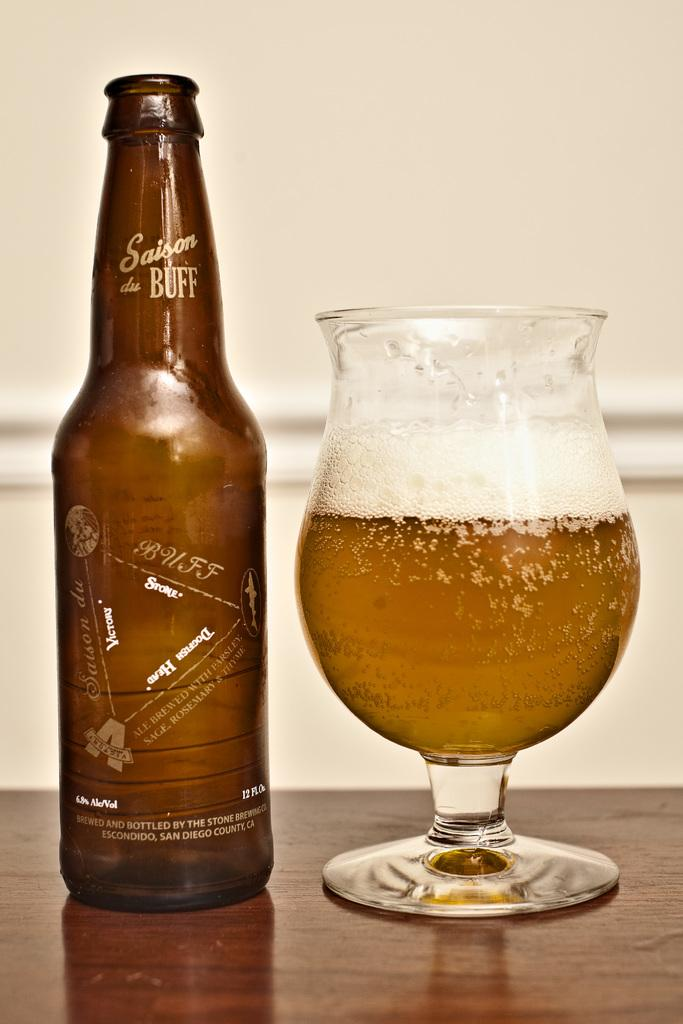What is present on the table in the image? There is a bottle and a glass on the table in the image. What is the purpose of the bottle and the glass? The bottle and the glass are likely used for holding and serving liquids. What can be seen in the background of the image? There is a wall visible in the background of the image. What type of pain is the person experiencing in the image? There is no person present in the image, and therefore no indication of any pain being experienced. 